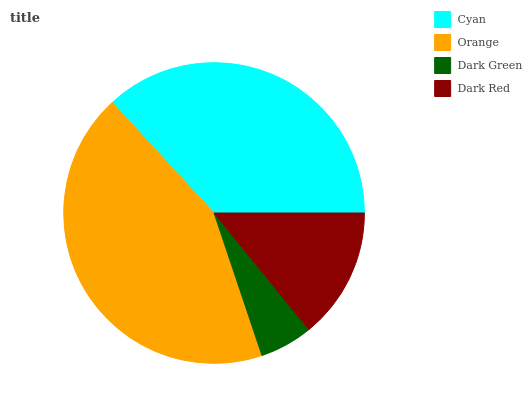Is Dark Green the minimum?
Answer yes or no. Yes. Is Orange the maximum?
Answer yes or no. Yes. Is Orange the minimum?
Answer yes or no. No. Is Dark Green the maximum?
Answer yes or no. No. Is Orange greater than Dark Green?
Answer yes or no. Yes. Is Dark Green less than Orange?
Answer yes or no. Yes. Is Dark Green greater than Orange?
Answer yes or no. No. Is Orange less than Dark Green?
Answer yes or no. No. Is Cyan the high median?
Answer yes or no. Yes. Is Dark Red the low median?
Answer yes or no. Yes. Is Dark Green the high median?
Answer yes or no. No. Is Cyan the low median?
Answer yes or no. No. 